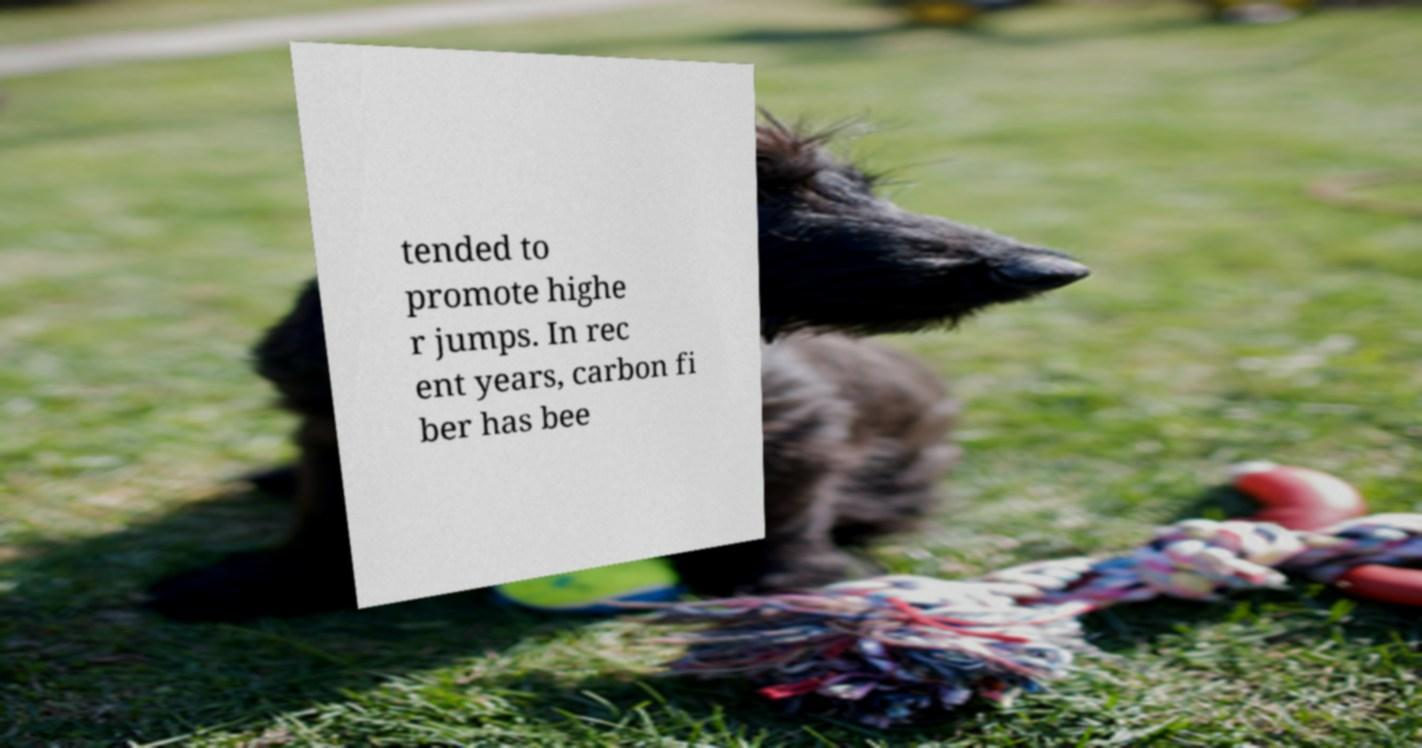Can you read and provide the text displayed in the image?This photo seems to have some interesting text. Can you extract and type it out for me? tended to promote highe r jumps. In rec ent years, carbon fi ber has bee 